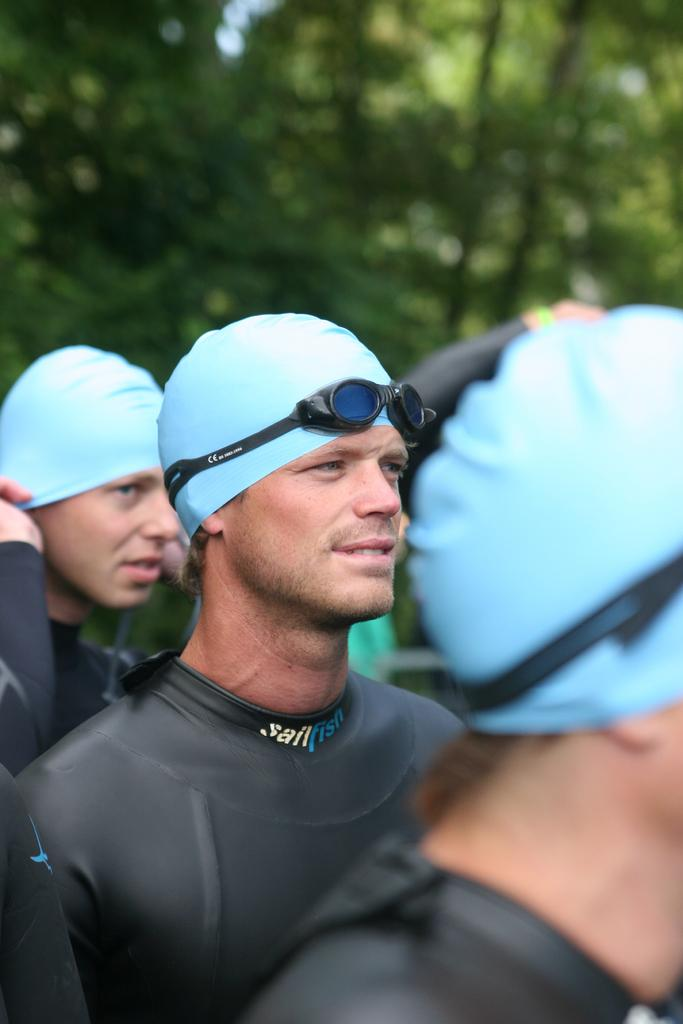Who or what is present in the image? There are people in the image. What are the people wearing? The people are wearing black color swimsuits. Where are the people positioned in the image? The people are standing in the front. What can be seen in the background of the image? There are trees in the background of the image. How is the background of the image depicted? The background is slightly blurred. What type of pipe can be seen in the image? There is no pipe present in the image. Is there a letter being delivered by an airplane in the image? There is no airplane or letter depicted in the image. 